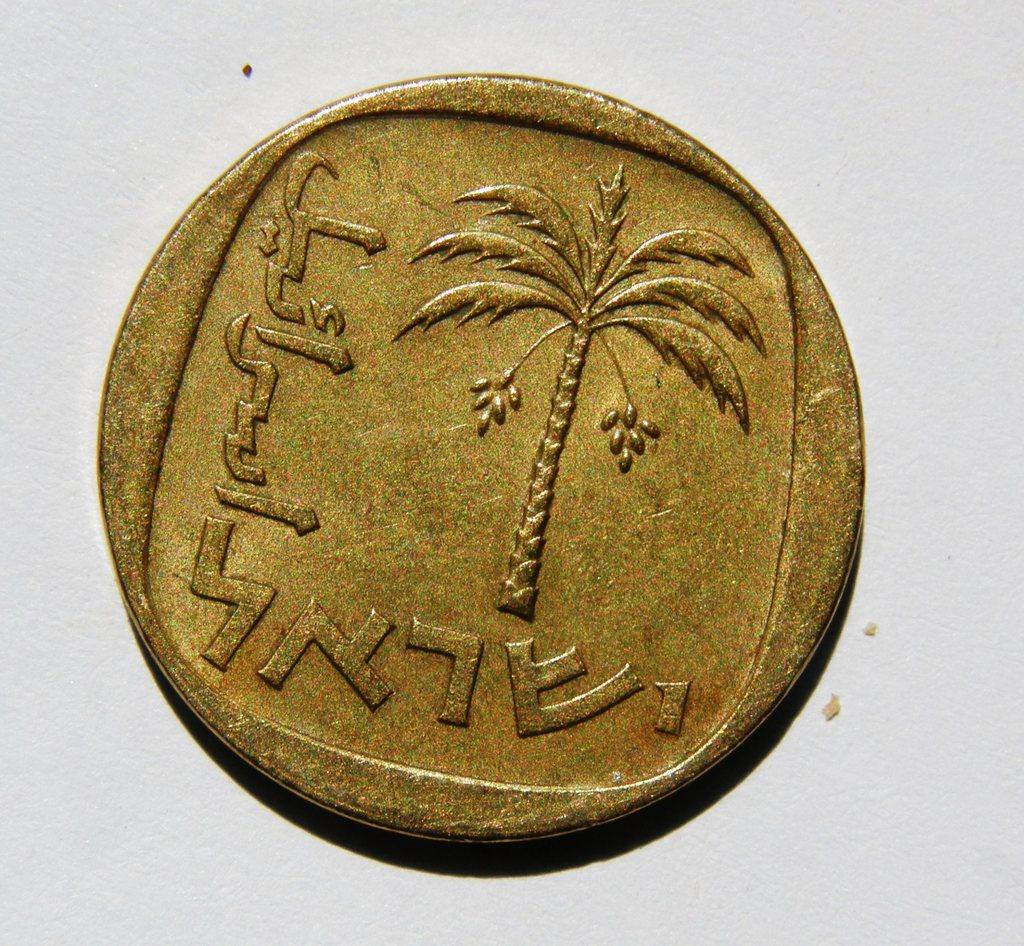<image>
Share a concise interpretation of the image provided. A gold piece featuring a palm tree and some foreign text along the left and bottom. 